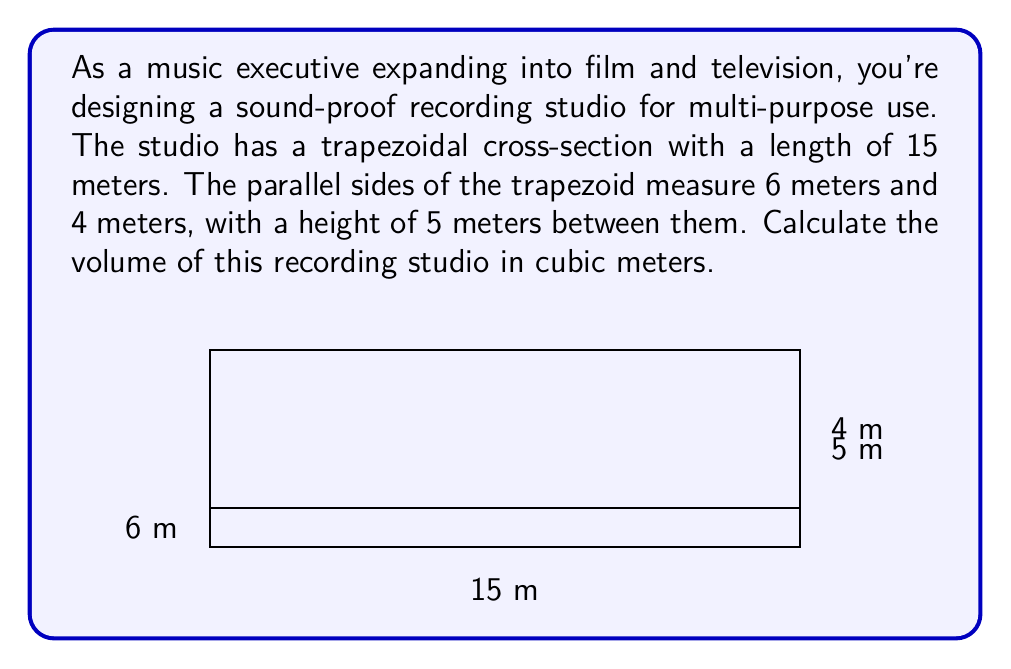Could you help me with this problem? To find the volume of the recording studio, we need to use the formula for the volume of a prism with a trapezoidal base. Let's break it down step-by-step:

1) The volume of a prism is given by the formula:
   $$V = A \cdot l$$
   where $V$ is the volume, $A$ is the area of the base, and $l$ is the length of the prism.

2) In this case, the base is a trapezoid. The area of a trapezoid is given by:
   $$A = \frac{1}{2}(a+b)h$$
   where $a$ and $b$ are the lengths of the parallel sides, and $h$ is the height between them.

3) Let's calculate the area of the trapezoidal cross-section:
   $$A = \frac{1}{2}(6+4) \cdot 5 = \frac{1}{2} \cdot 10 \cdot 5 = 25 \text{ m}^2$$

4) Now that we have the area of the base, we can calculate the volume by multiplying by the length:
   $$V = A \cdot l = 25 \cdot 15 = 375 \text{ m}^3$$

Therefore, the volume of the recording studio is 375 cubic meters.
Answer: 375 m³ 